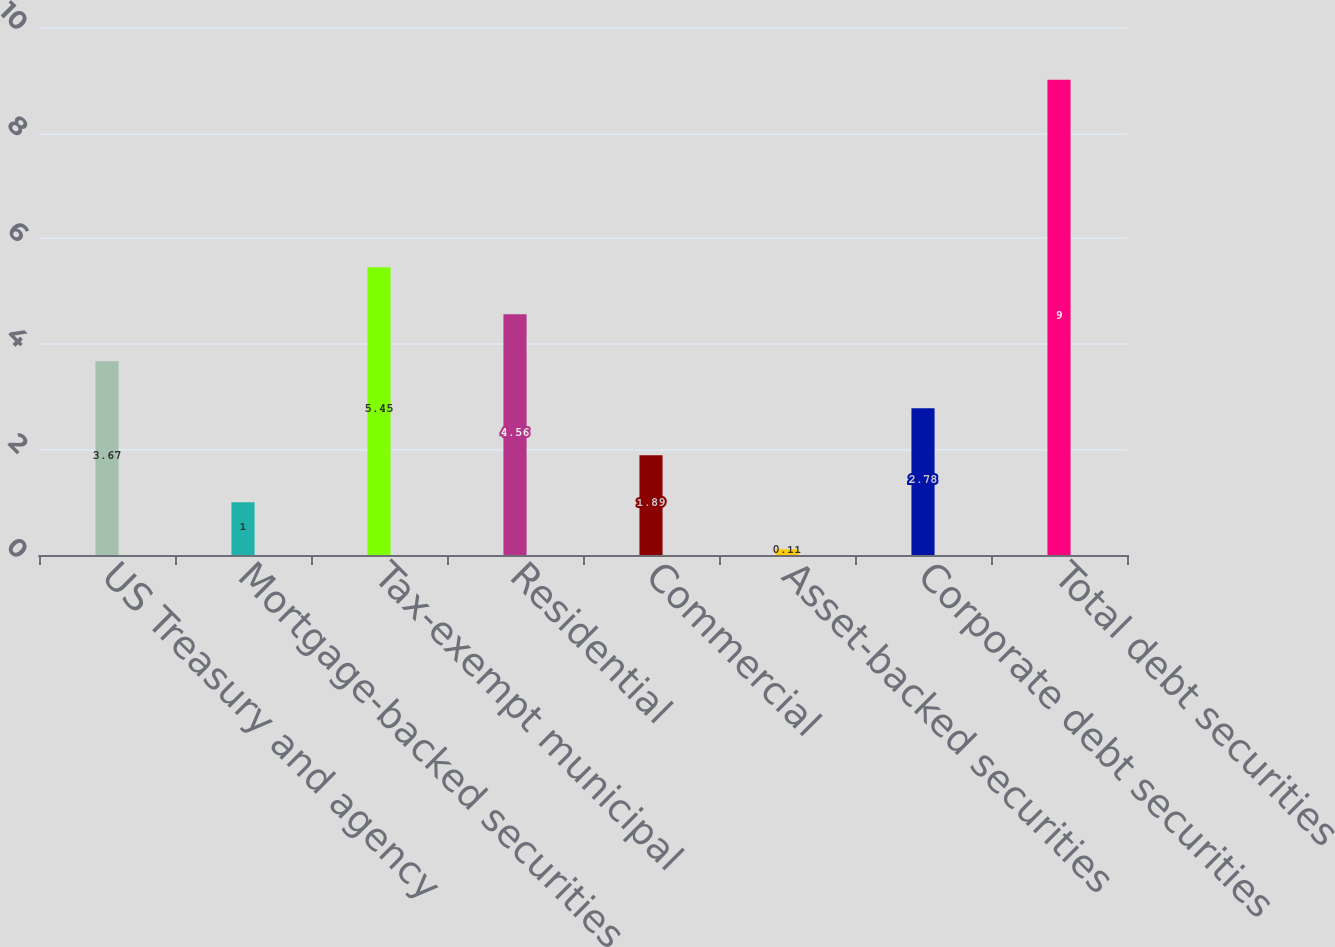<chart> <loc_0><loc_0><loc_500><loc_500><bar_chart><fcel>US Treasury and agency<fcel>Mortgage-backed securities<fcel>Tax-exempt municipal<fcel>Residential<fcel>Commercial<fcel>Asset-backed securities<fcel>Corporate debt securities<fcel>Total debt securities<nl><fcel>3.67<fcel>1<fcel>5.45<fcel>4.56<fcel>1.89<fcel>0.11<fcel>2.78<fcel>9<nl></chart> 